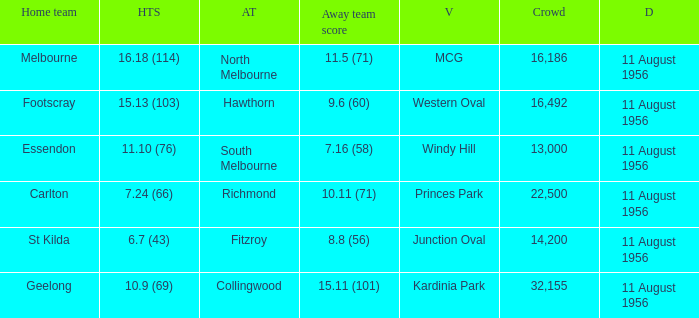Where did a home team score 10.9 (69)? Kardinia Park. 